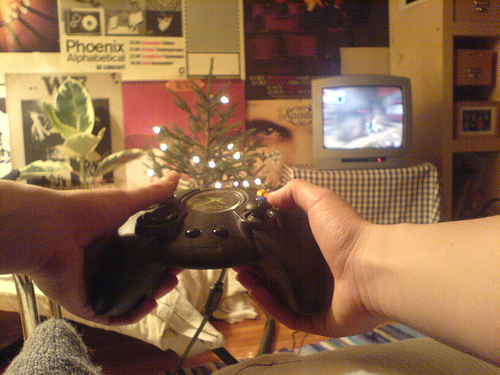<image>
Is there a tv next to the wall? Yes. The tv is positioned adjacent to the wall, located nearby in the same general area. Where is the television in relation to the man? Is it next to the man? No. The television is not positioned next to the man. They are located in different areas of the scene. Is there a tree in front of the controller? Yes. The tree is positioned in front of the controller, appearing closer to the camera viewpoint. 